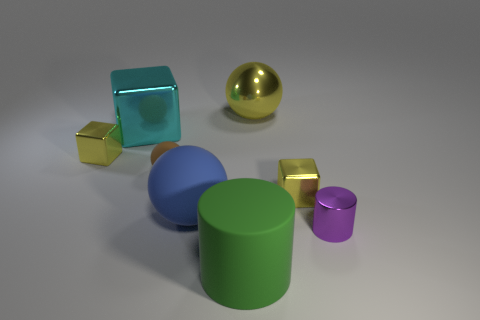Does the blue matte thing in front of the brown ball have the same size as the ball on the left side of the blue object?
Your answer should be very brief. No. What is the size of the cylinder in front of the purple thing?
Provide a short and direct response. Large. Is there a big shiny object of the same color as the large matte ball?
Your answer should be compact. No. There is a small yellow object to the left of the large green thing; are there any cyan blocks that are behind it?
Your response must be concise. Yes. Does the purple shiny thing have the same size as the object that is in front of the small purple metallic cylinder?
Offer a very short reply. No. There is a yellow metallic thing that is behind the small yellow cube that is on the left side of the big blue rubber sphere; are there any big shiny spheres to the right of it?
Offer a terse response. No. There is a yellow cube that is right of the large metallic sphere; what is it made of?
Your answer should be very brief. Metal. Is the metal cylinder the same size as the yellow metal sphere?
Your answer should be very brief. No. What color is the object that is behind the large blue sphere and in front of the tiny brown matte thing?
Make the answer very short. Yellow. The large blue object that is made of the same material as the brown ball is what shape?
Keep it short and to the point. Sphere. 